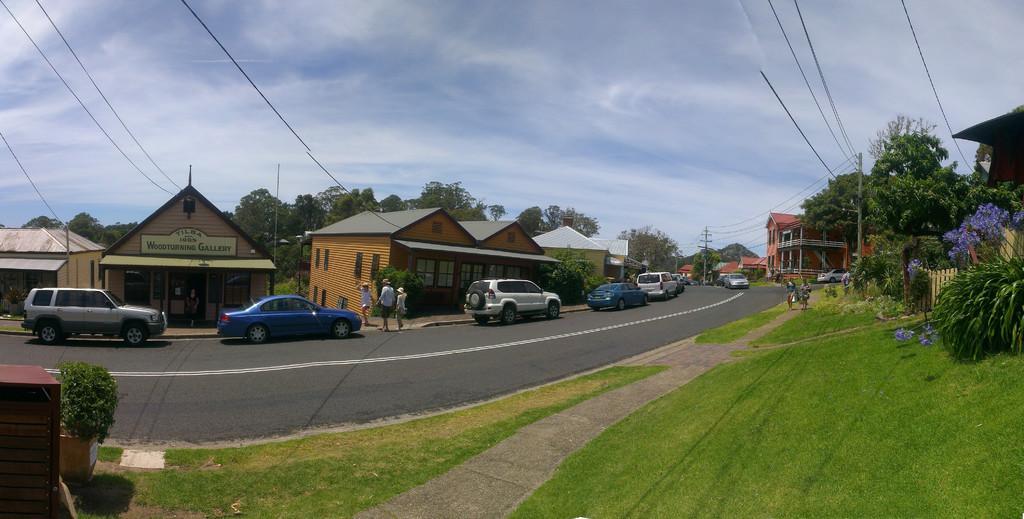Describe this image in one or two sentences. In this image we can see some buildings, vehicles, poles, people, road, trees and other objects. At the top of the image there is the sky and cables. At the bottom of the image there is the grass and a walkway. On the right side of the image there are plants, flowers and other objects. On the left side of the image there is a plant and an object. 